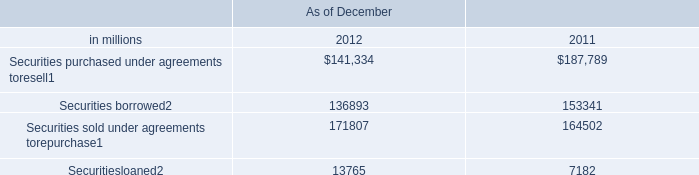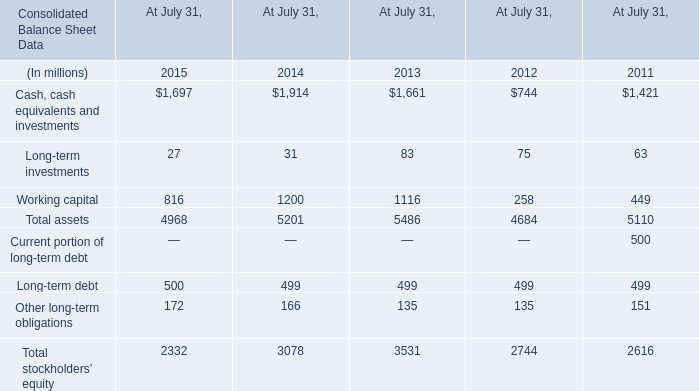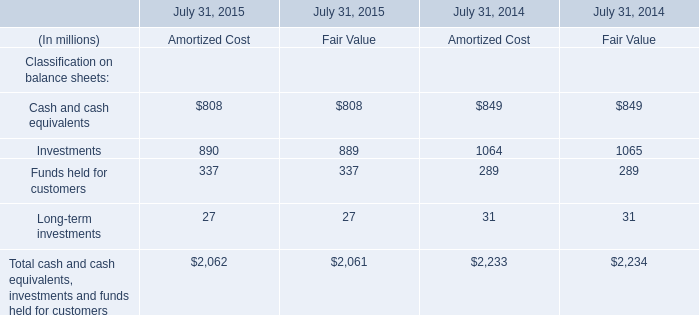What's the average of Securities borrowed of As of December 2012, and Investments of July 31, 2014 Fair Value ? 
Computations: ((136893.0 + 1065.0) / 2)
Answer: 68979.0. 